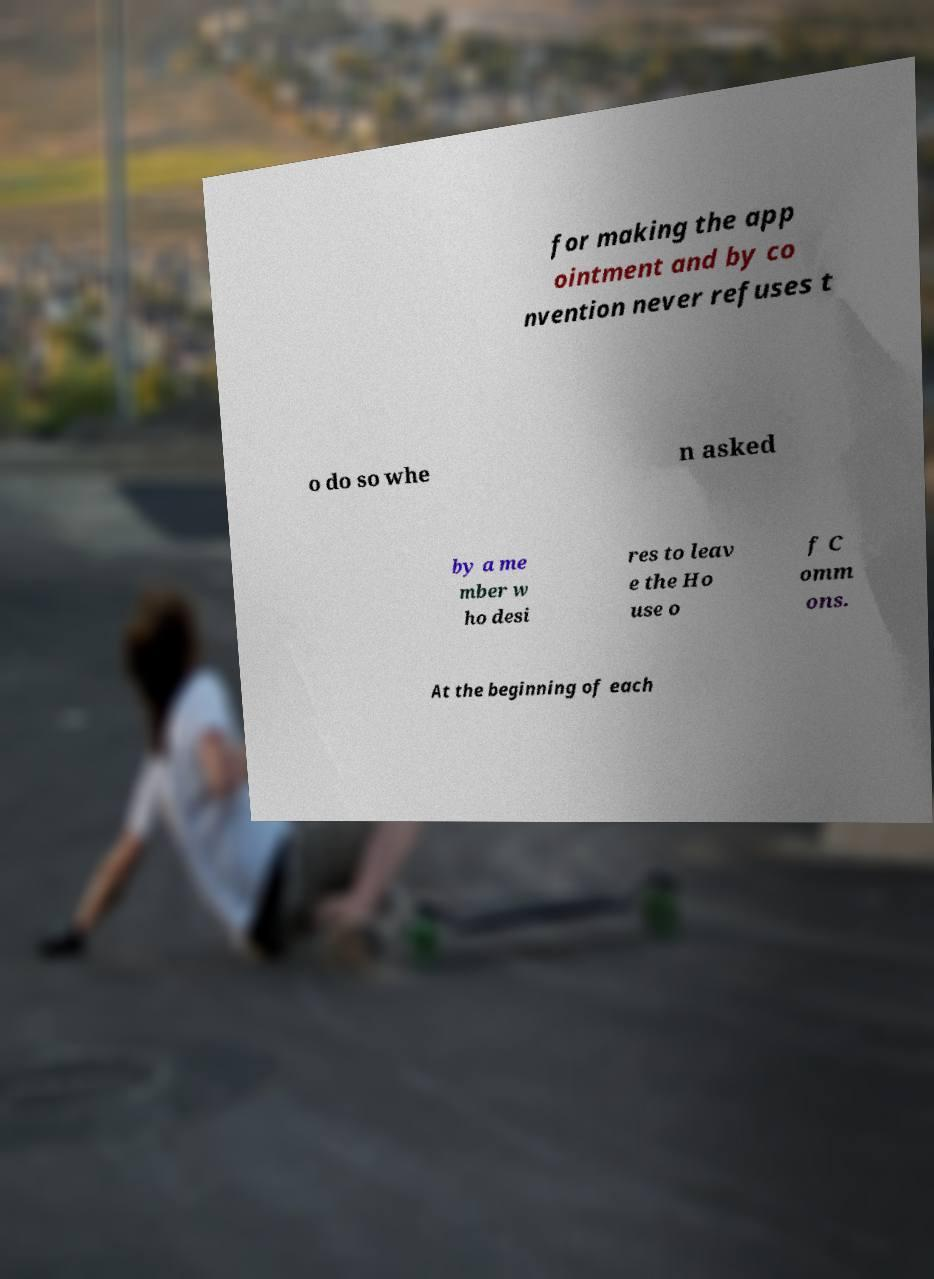Can you read and provide the text displayed in the image?This photo seems to have some interesting text. Can you extract and type it out for me? for making the app ointment and by co nvention never refuses t o do so whe n asked by a me mber w ho desi res to leav e the Ho use o f C omm ons. At the beginning of each 